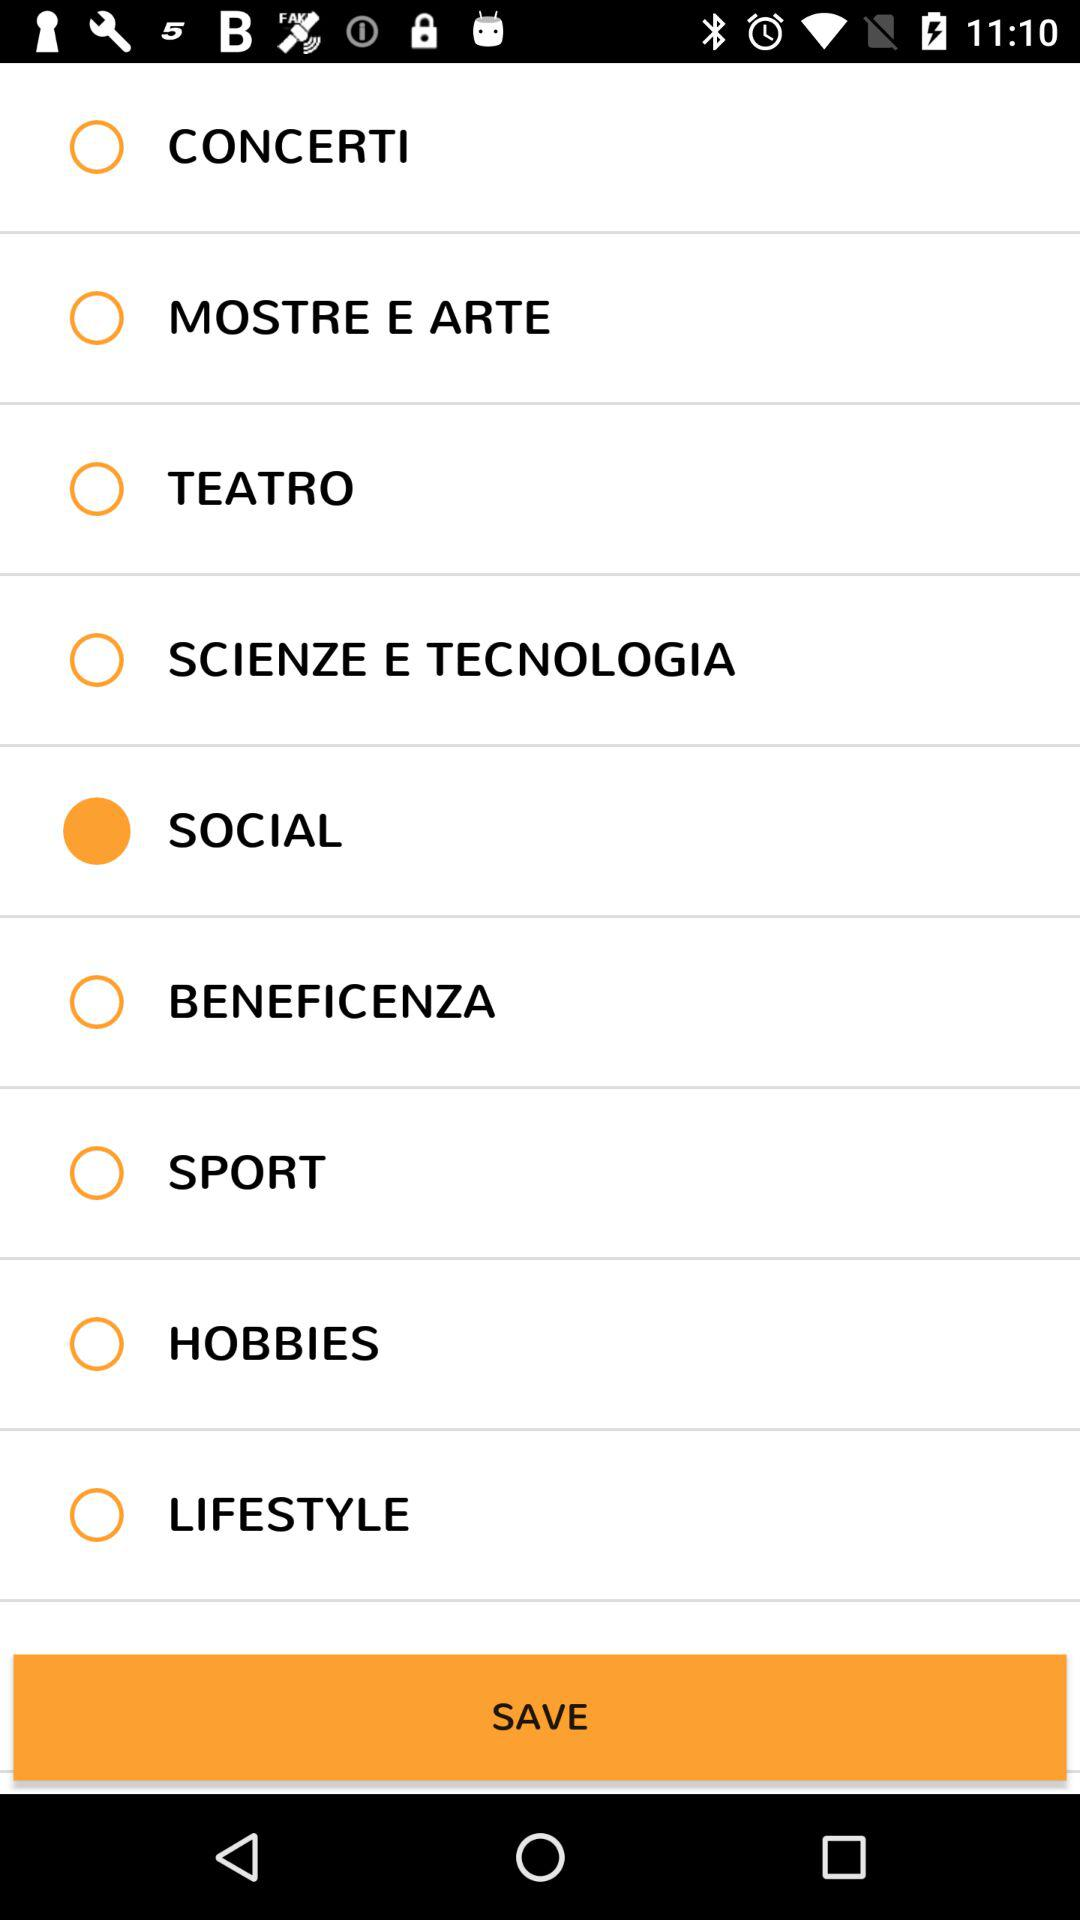What is the email id used for sign in?
When the provided information is insufficient, respond with <no answer>. <no answer> 